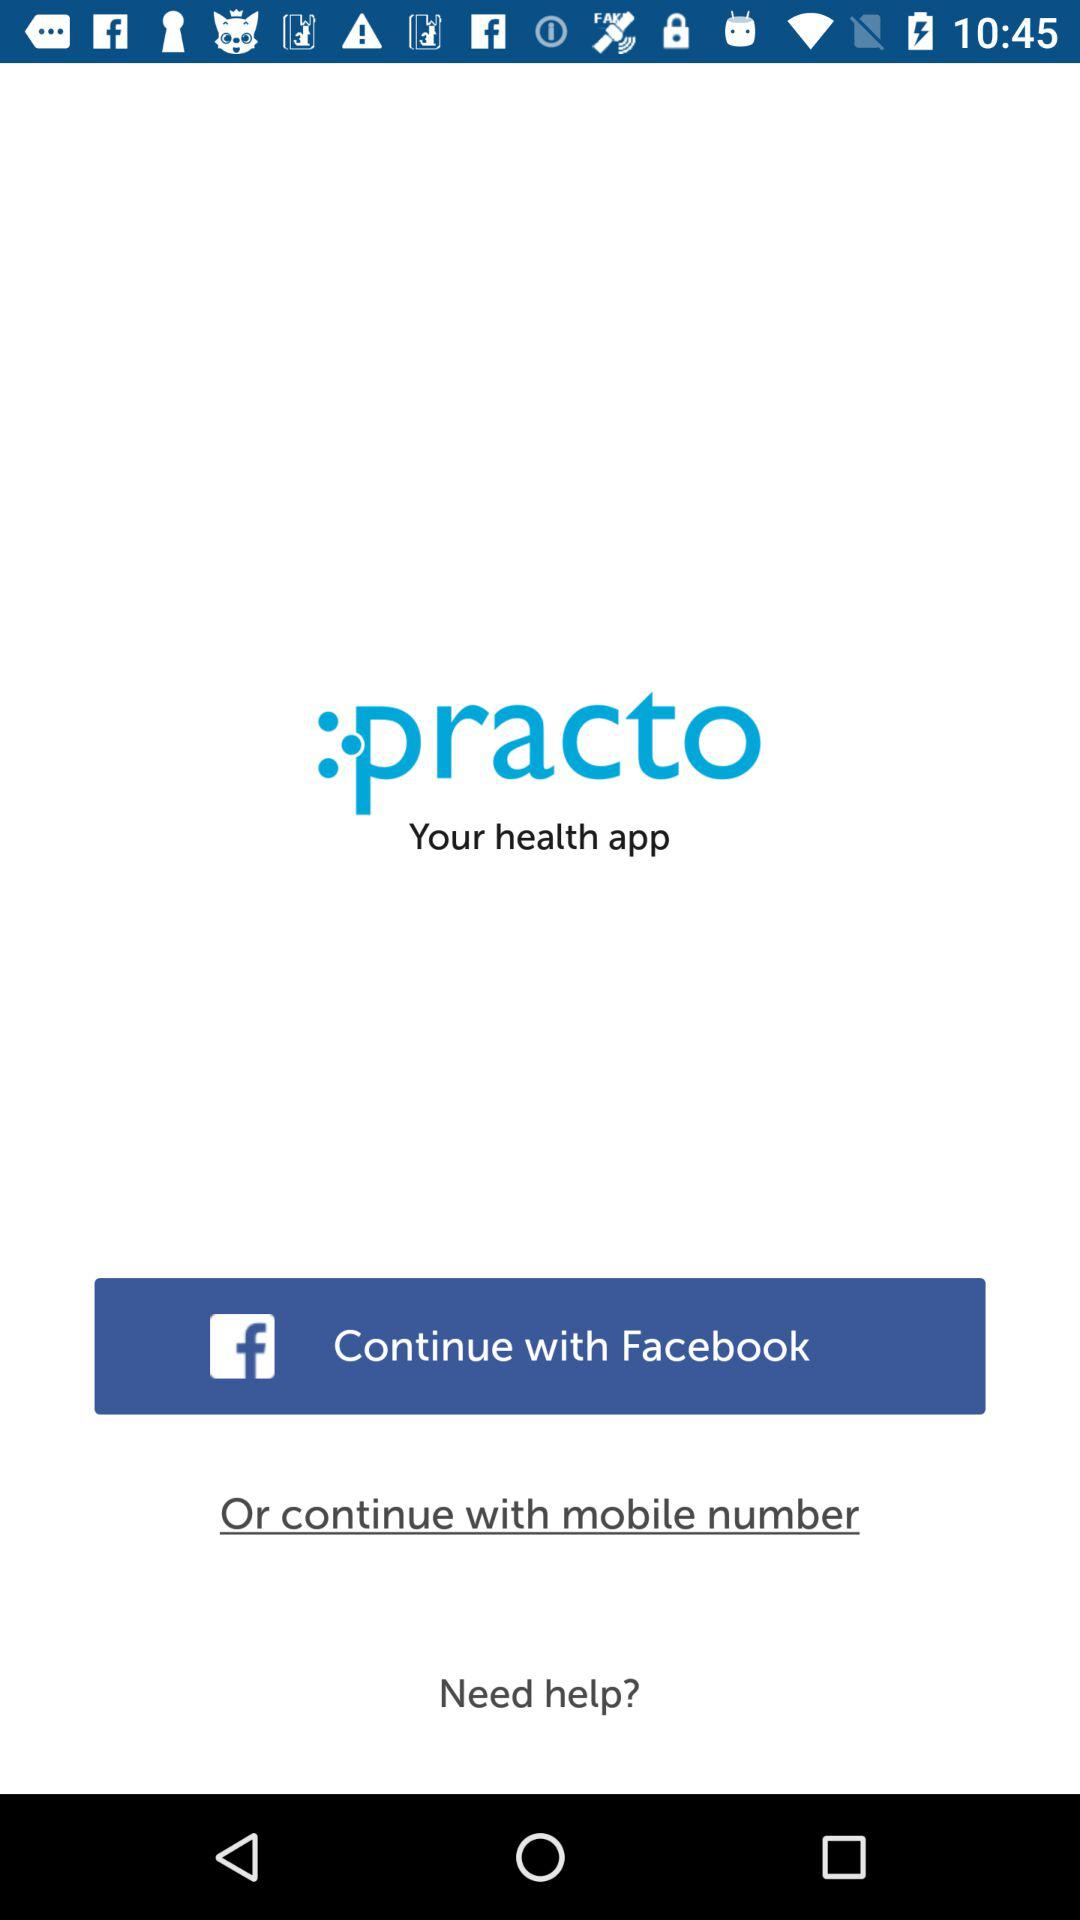What options are given to continue with? The options are "Facebook" and "mobile number". 